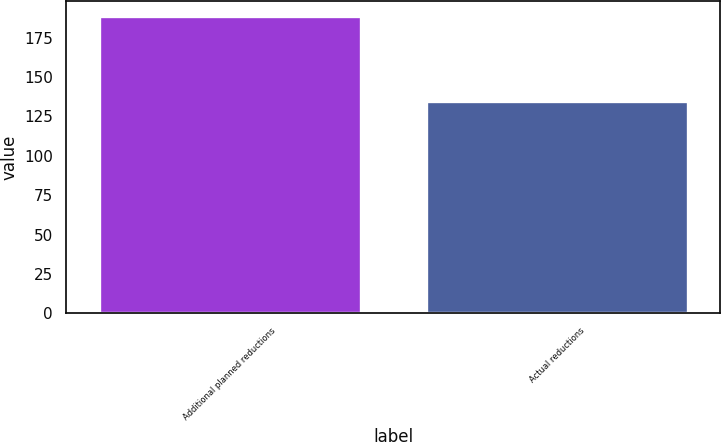Convert chart to OTSL. <chart><loc_0><loc_0><loc_500><loc_500><bar_chart><fcel>Additional planned reductions<fcel>Actual reductions<nl><fcel>189<fcel>135<nl></chart> 